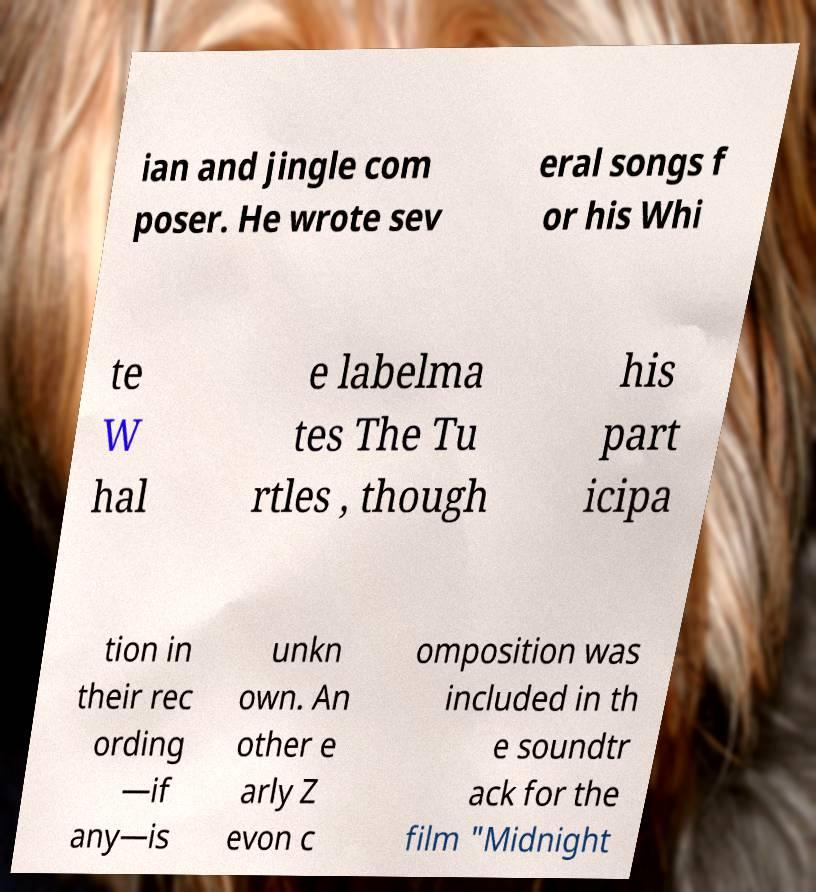What messages or text are displayed in this image? I need them in a readable, typed format. ian and jingle com poser. He wrote sev eral songs f or his Whi te W hal e labelma tes The Tu rtles , though his part icipa tion in their rec ording —if any—is unkn own. An other e arly Z evon c omposition was included in th e soundtr ack for the film "Midnight 